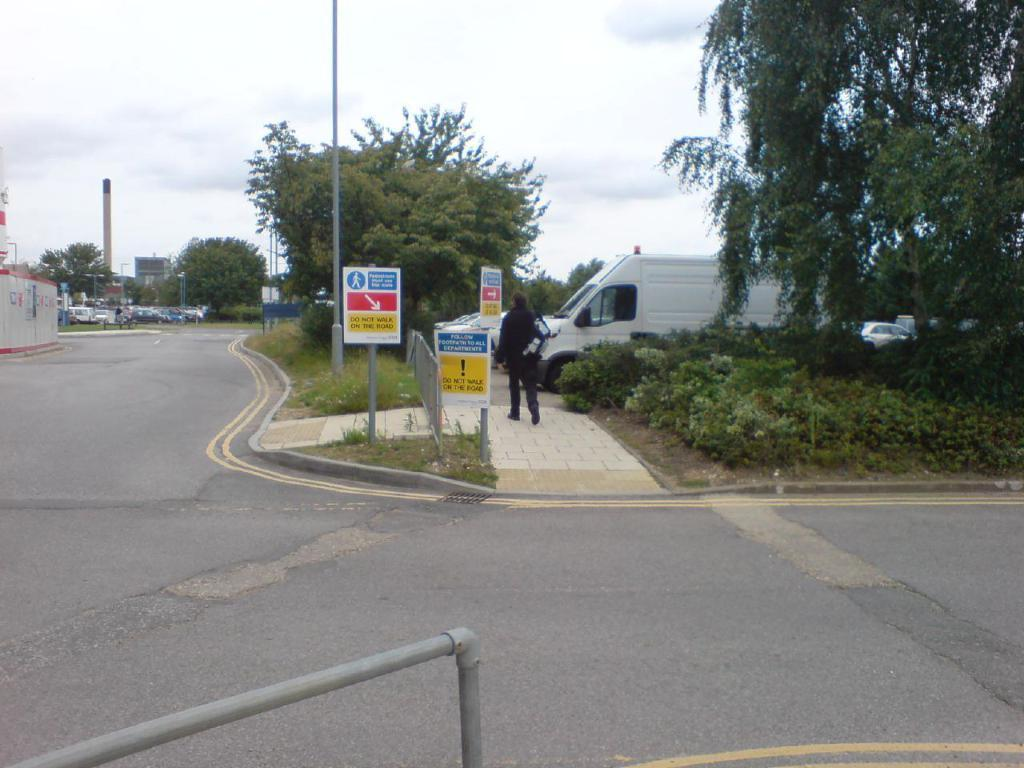<image>
Summarize the visual content of the image. A number of signs tell people to not walk in the road. 